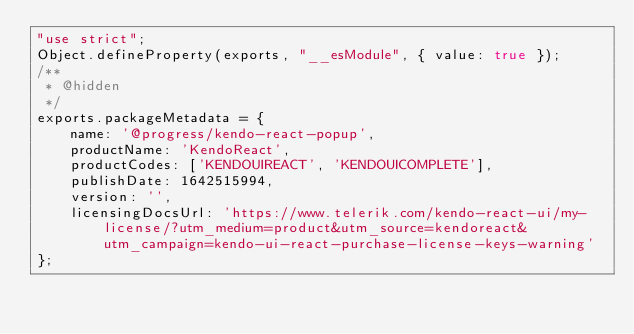<code> <loc_0><loc_0><loc_500><loc_500><_JavaScript_>"use strict";
Object.defineProperty(exports, "__esModule", { value: true });
/**
 * @hidden
 */
exports.packageMetadata = {
    name: '@progress/kendo-react-popup',
    productName: 'KendoReact',
    productCodes: ['KENDOUIREACT', 'KENDOUICOMPLETE'],
    publishDate: 1642515994,
    version: '',
    licensingDocsUrl: 'https://www.telerik.com/kendo-react-ui/my-license/?utm_medium=product&utm_source=kendoreact&utm_campaign=kendo-ui-react-purchase-license-keys-warning'
};
</code> 